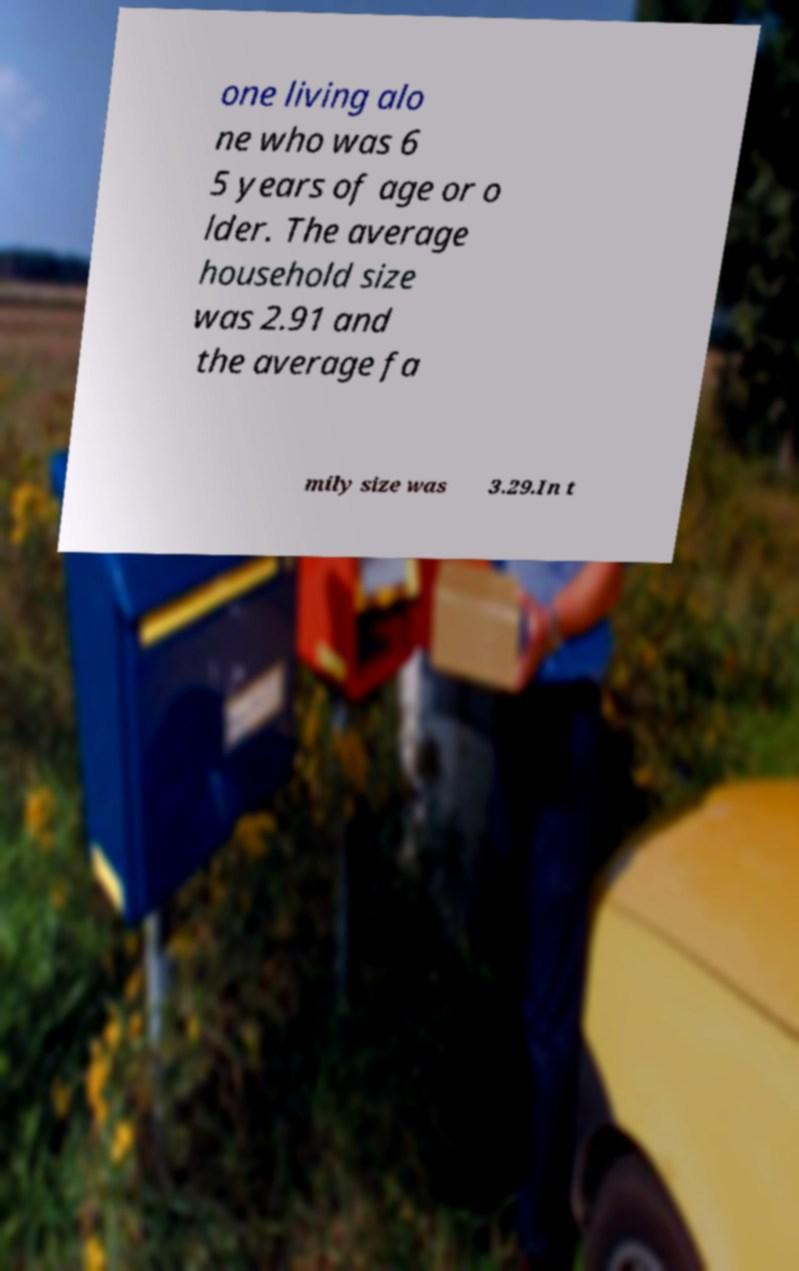I need the written content from this picture converted into text. Can you do that? one living alo ne who was 6 5 years of age or o lder. The average household size was 2.91 and the average fa mily size was 3.29.In t 